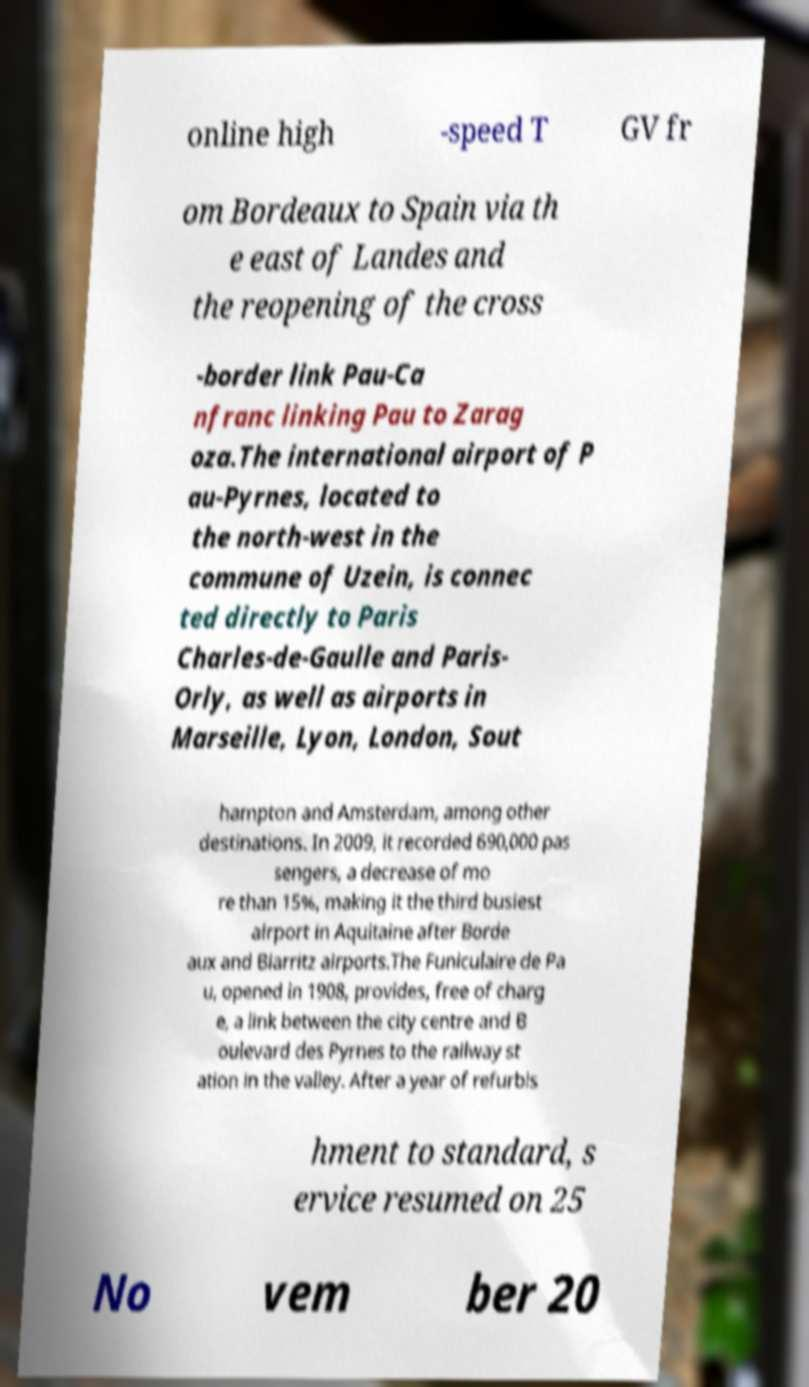Please read and relay the text visible in this image. What does it say? online high -speed T GV fr om Bordeaux to Spain via th e east of Landes and the reopening of the cross -border link Pau-Ca nfranc linking Pau to Zarag oza.The international airport of P au-Pyrnes, located to the north-west in the commune of Uzein, is connec ted directly to Paris Charles-de-Gaulle and Paris- Orly, as well as airports in Marseille, Lyon, London, Sout hampton and Amsterdam, among other destinations. In 2009, it recorded 690,000 pas sengers, a decrease of mo re than 15%, making it the third busiest airport in Aquitaine after Borde aux and Biarritz airports.The Funiculaire de Pa u, opened in 1908, provides, free of charg e, a link between the city centre and B oulevard des Pyrnes to the railway st ation in the valley. After a year of refurbis hment to standard, s ervice resumed on 25 No vem ber 20 